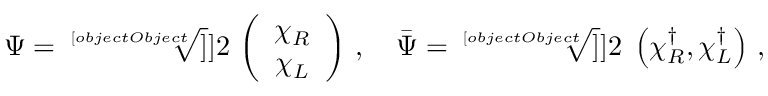<formula> <loc_0><loc_0><loc_500><loc_500>\Psi = \sqrt { [ } [ o b j e c t O b j e c t ] ] ] { 2 } \, \left ( \begin{array} { c } { { \chi _ { R } } } \\ { { \chi _ { L } } } \end{array} \right ) \, , \quad \bar { \Psi } = \sqrt { [ } [ o b j e c t O b j e c t ] ] ] { 2 } \, \left ( \chi _ { R } ^ { \dag } , \chi _ { L } ^ { \dag } \right ) \, ,</formula> 